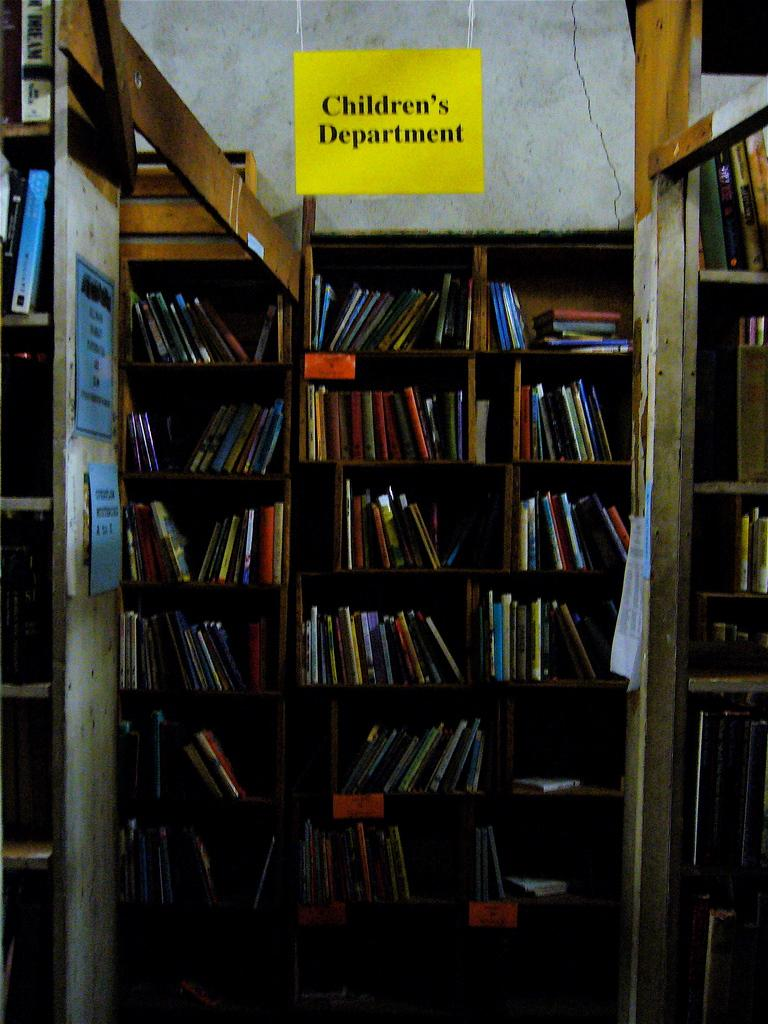<image>
Create a compact narrative representing the image presented. Library shelving with many books and above is a yellow sign with black Children's Department lettering 